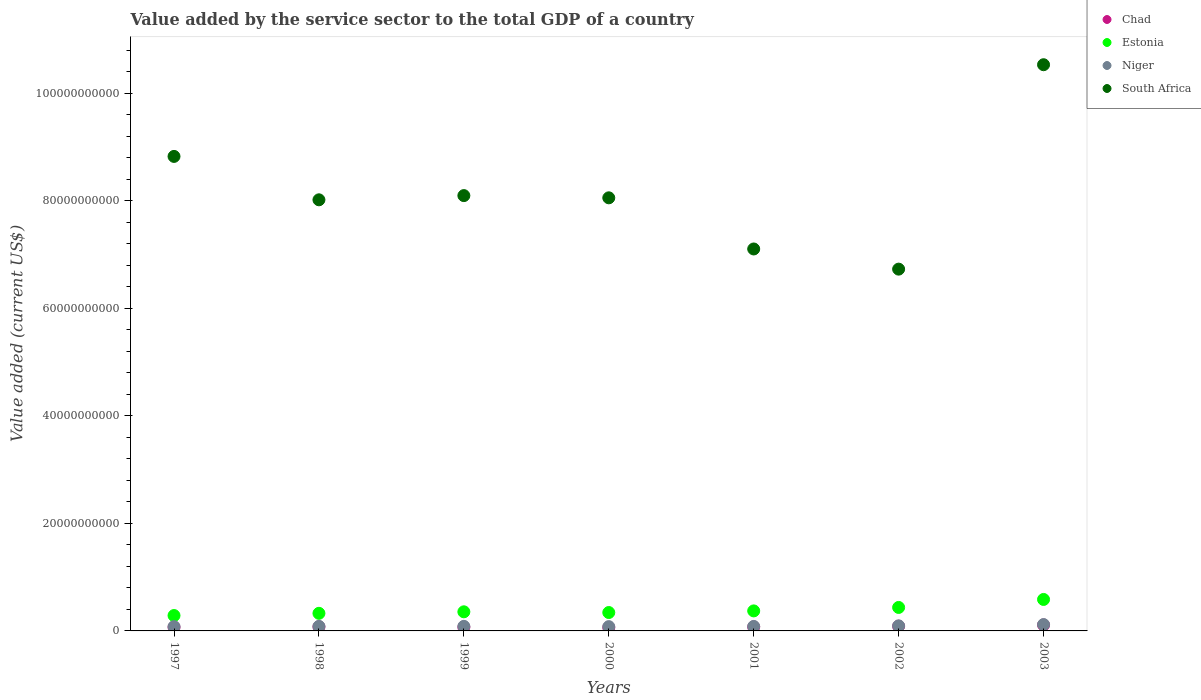What is the value added by the service sector to the total GDP in Estonia in 2000?
Your answer should be compact. 3.42e+09. Across all years, what is the maximum value added by the service sector to the total GDP in Chad?
Provide a succinct answer. 1.11e+09. Across all years, what is the minimum value added by the service sector to the total GDP in Estonia?
Provide a succinct answer. 2.86e+09. In which year was the value added by the service sector to the total GDP in South Africa maximum?
Make the answer very short. 2003. In which year was the value added by the service sector to the total GDP in Estonia minimum?
Ensure brevity in your answer.  1997. What is the total value added by the service sector to the total GDP in Niger in the graph?
Make the answer very short. 6.25e+09. What is the difference between the value added by the service sector to the total GDP in Estonia in 1999 and that in 2002?
Ensure brevity in your answer.  -8.11e+08. What is the difference between the value added by the service sector to the total GDP in Niger in 1998 and the value added by the service sector to the total GDP in Chad in 1997?
Offer a terse response. 1.65e+08. What is the average value added by the service sector to the total GDP in Niger per year?
Your answer should be compact. 8.93e+08. In the year 1999, what is the difference between the value added by the service sector to the total GDP in South Africa and value added by the service sector to the total GDP in Chad?
Offer a terse response. 8.03e+1. In how many years, is the value added by the service sector to the total GDP in Estonia greater than 44000000000 US$?
Give a very brief answer. 0. What is the ratio of the value added by the service sector to the total GDP in Chad in 2001 to that in 2003?
Your answer should be very brief. 0.66. Is the value added by the service sector to the total GDP in South Africa in 1998 less than that in 2000?
Provide a succinct answer. Yes. Is the difference between the value added by the service sector to the total GDP in South Africa in 1999 and 2002 greater than the difference between the value added by the service sector to the total GDP in Chad in 1999 and 2002?
Keep it short and to the point. Yes. What is the difference between the highest and the second highest value added by the service sector to the total GDP in Estonia?
Make the answer very short. 1.49e+09. What is the difference between the highest and the lowest value added by the service sector to the total GDP in Chad?
Your response must be concise. 4.88e+08. Is the sum of the value added by the service sector to the total GDP in South Africa in 1997 and 1998 greater than the maximum value added by the service sector to the total GDP in Chad across all years?
Keep it short and to the point. Yes. Is it the case that in every year, the sum of the value added by the service sector to the total GDP in Chad and value added by the service sector to the total GDP in South Africa  is greater than the sum of value added by the service sector to the total GDP in Niger and value added by the service sector to the total GDP in Estonia?
Ensure brevity in your answer.  Yes. Does the value added by the service sector to the total GDP in Estonia monotonically increase over the years?
Offer a very short reply. No. Is the value added by the service sector to the total GDP in Niger strictly greater than the value added by the service sector to the total GDP in Estonia over the years?
Offer a terse response. No. Is the value added by the service sector to the total GDP in South Africa strictly less than the value added by the service sector to the total GDP in Niger over the years?
Your response must be concise. No. How many dotlines are there?
Ensure brevity in your answer.  4. How many years are there in the graph?
Offer a terse response. 7. Does the graph contain grids?
Ensure brevity in your answer.  No. How are the legend labels stacked?
Your answer should be compact. Vertical. What is the title of the graph?
Make the answer very short. Value added by the service sector to the total GDP of a country. Does "Mauritius" appear as one of the legend labels in the graph?
Give a very brief answer. No. What is the label or title of the Y-axis?
Provide a short and direct response. Value added (current US$). What is the Value added (current US$) in Chad in 1997?
Your response must be concise. 6.79e+08. What is the Value added (current US$) in Estonia in 1997?
Your response must be concise. 2.86e+09. What is the Value added (current US$) in Niger in 1997?
Ensure brevity in your answer.  7.98e+08. What is the Value added (current US$) in South Africa in 1997?
Your response must be concise. 8.83e+1. What is the Value added (current US$) in Chad in 1998?
Keep it short and to the point. 7.62e+08. What is the Value added (current US$) of Estonia in 1998?
Your response must be concise. 3.27e+09. What is the Value added (current US$) of Niger in 1998?
Offer a very short reply. 8.44e+08. What is the Value added (current US$) in South Africa in 1998?
Keep it short and to the point. 8.02e+1. What is the Value added (current US$) in Chad in 1999?
Offer a terse response. 6.98e+08. What is the Value added (current US$) in Estonia in 1999?
Make the answer very short. 3.55e+09. What is the Value added (current US$) of Niger in 1999?
Keep it short and to the point. 8.50e+08. What is the Value added (current US$) in South Africa in 1999?
Your answer should be compact. 8.10e+1. What is the Value added (current US$) in Chad in 2000?
Give a very brief answer. 6.17e+08. What is the Value added (current US$) of Estonia in 2000?
Offer a very short reply. 3.42e+09. What is the Value added (current US$) in Niger in 2000?
Offer a very short reply. 7.98e+08. What is the Value added (current US$) of South Africa in 2000?
Offer a very short reply. 8.05e+1. What is the Value added (current US$) of Chad in 2001?
Your answer should be compact. 7.35e+08. What is the Value added (current US$) in Estonia in 2001?
Offer a very short reply. 3.72e+09. What is the Value added (current US$) of Niger in 2001?
Provide a short and direct response. 8.37e+08. What is the Value added (current US$) in South Africa in 2001?
Ensure brevity in your answer.  7.10e+1. What is the Value added (current US$) of Chad in 2002?
Ensure brevity in your answer.  8.73e+08. What is the Value added (current US$) in Estonia in 2002?
Offer a very short reply. 4.37e+09. What is the Value added (current US$) of Niger in 2002?
Give a very brief answer. 9.43e+08. What is the Value added (current US$) in South Africa in 2002?
Your response must be concise. 6.73e+1. What is the Value added (current US$) of Chad in 2003?
Offer a very short reply. 1.11e+09. What is the Value added (current US$) in Estonia in 2003?
Your answer should be compact. 5.85e+09. What is the Value added (current US$) of Niger in 2003?
Provide a short and direct response. 1.18e+09. What is the Value added (current US$) in South Africa in 2003?
Your answer should be very brief. 1.05e+11. Across all years, what is the maximum Value added (current US$) in Chad?
Your response must be concise. 1.11e+09. Across all years, what is the maximum Value added (current US$) in Estonia?
Make the answer very short. 5.85e+09. Across all years, what is the maximum Value added (current US$) in Niger?
Ensure brevity in your answer.  1.18e+09. Across all years, what is the maximum Value added (current US$) of South Africa?
Offer a terse response. 1.05e+11. Across all years, what is the minimum Value added (current US$) of Chad?
Make the answer very short. 6.17e+08. Across all years, what is the minimum Value added (current US$) of Estonia?
Offer a very short reply. 2.86e+09. Across all years, what is the minimum Value added (current US$) of Niger?
Keep it short and to the point. 7.98e+08. Across all years, what is the minimum Value added (current US$) of South Africa?
Offer a terse response. 6.73e+1. What is the total Value added (current US$) of Chad in the graph?
Offer a very short reply. 5.47e+09. What is the total Value added (current US$) in Estonia in the graph?
Make the answer very short. 2.71e+1. What is the total Value added (current US$) in Niger in the graph?
Your response must be concise. 6.25e+09. What is the total Value added (current US$) of South Africa in the graph?
Offer a terse response. 5.74e+11. What is the difference between the Value added (current US$) in Chad in 1997 and that in 1998?
Offer a very short reply. -8.28e+07. What is the difference between the Value added (current US$) of Estonia in 1997 and that in 1998?
Provide a short and direct response. -4.10e+08. What is the difference between the Value added (current US$) in Niger in 1997 and that in 1998?
Offer a terse response. -4.69e+07. What is the difference between the Value added (current US$) of South Africa in 1997 and that in 1998?
Provide a short and direct response. 8.07e+09. What is the difference between the Value added (current US$) of Chad in 1997 and that in 1999?
Ensure brevity in your answer.  -1.88e+07. What is the difference between the Value added (current US$) in Estonia in 1997 and that in 1999?
Offer a terse response. -6.93e+08. What is the difference between the Value added (current US$) in Niger in 1997 and that in 1999?
Give a very brief answer. -5.24e+07. What is the difference between the Value added (current US$) in South Africa in 1997 and that in 1999?
Offer a very short reply. 7.29e+09. What is the difference between the Value added (current US$) in Chad in 1997 and that in 2000?
Your answer should be very brief. 6.20e+07. What is the difference between the Value added (current US$) in Estonia in 1997 and that in 2000?
Make the answer very short. -5.60e+08. What is the difference between the Value added (current US$) of Niger in 1997 and that in 2000?
Give a very brief answer. -9.07e+05. What is the difference between the Value added (current US$) of South Africa in 1997 and that in 2000?
Your response must be concise. 7.70e+09. What is the difference between the Value added (current US$) of Chad in 1997 and that in 2001?
Your response must be concise. -5.56e+07. What is the difference between the Value added (current US$) in Estonia in 1997 and that in 2001?
Make the answer very short. -8.62e+08. What is the difference between the Value added (current US$) of Niger in 1997 and that in 2001?
Your answer should be very brief. -3.89e+07. What is the difference between the Value added (current US$) of South Africa in 1997 and that in 2001?
Your answer should be very brief. 1.72e+1. What is the difference between the Value added (current US$) in Chad in 1997 and that in 2002?
Your answer should be very brief. -1.94e+08. What is the difference between the Value added (current US$) in Estonia in 1997 and that in 2002?
Your answer should be very brief. -1.50e+09. What is the difference between the Value added (current US$) in Niger in 1997 and that in 2002?
Ensure brevity in your answer.  -1.45e+08. What is the difference between the Value added (current US$) in South Africa in 1997 and that in 2002?
Give a very brief answer. 2.10e+1. What is the difference between the Value added (current US$) in Chad in 1997 and that in 2003?
Provide a succinct answer. -4.26e+08. What is the difference between the Value added (current US$) of Estonia in 1997 and that in 2003?
Offer a very short reply. -2.99e+09. What is the difference between the Value added (current US$) in Niger in 1997 and that in 2003?
Keep it short and to the point. -3.83e+08. What is the difference between the Value added (current US$) in South Africa in 1997 and that in 2003?
Your response must be concise. -1.71e+1. What is the difference between the Value added (current US$) of Chad in 1998 and that in 1999?
Your answer should be compact. 6.40e+07. What is the difference between the Value added (current US$) of Estonia in 1998 and that in 1999?
Your answer should be compact. -2.82e+08. What is the difference between the Value added (current US$) of Niger in 1998 and that in 1999?
Give a very brief answer. -5.49e+06. What is the difference between the Value added (current US$) of South Africa in 1998 and that in 1999?
Make the answer very short. -7.83e+08. What is the difference between the Value added (current US$) of Chad in 1998 and that in 2000?
Provide a short and direct response. 1.45e+08. What is the difference between the Value added (current US$) in Estonia in 1998 and that in 2000?
Provide a short and direct response. -1.49e+08. What is the difference between the Value added (current US$) in Niger in 1998 and that in 2000?
Provide a succinct answer. 4.60e+07. What is the difference between the Value added (current US$) of South Africa in 1998 and that in 2000?
Ensure brevity in your answer.  -3.70e+08. What is the difference between the Value added (current US$) of Chad in 1998 and that in 2001?
Your answer should be compact. 2.72e+07. What is the difference between the Value added (current US$) of Estonia in 1998 and that in 2001?
Make the answer very short. -4.52e+08. What is the difference between the Value added (current US$) of Niger in 1998 and that in 2001?
Provide a succinct answer. 7.92e+06. What is the difference between the Value added (current US$) in South Africa in 1998 and that in 2001?
Your response must be concise. 9.14e+09. What is the difference between the Value added (current US$) in Chad in 1998 and that in 2002?
Your answer should be very brief. -1.11e+08. What is the difference between the Value added (current US$) in Estonia in 1998 and that in 2002?
Provide a short and direct response. -1.09e+09. What is the difference between the Value added (current US$) of Niger in 1998 and that in 2002?
Give a very brief answer. -9.85e+07. What is the difference between the Value added (current US$) in South Africa in 1998 and that in 2002?
Give a very brief answer. 1.29e+1. What is the difference between the Value added (current US$) in Chad in 1998 and that in 2003?
Provide a short and direct response. -3.43e+08. What is the difference between the Value added (current US$) in Estonia in 1998 and that in 2003?
Your answer should be very brief. -2.58e+09. What is the difference between the Value added (current US$) of Niger in 1998 and that in 2003?
Offer a terse response. -3.36e+08. What is the difference between the Value added (current US$) in South Africa in 1998 and that in 2003?
Provide a short and direct response. -2.51e+1. What is the difference between the Value added (current US$) of Chad in 1999 and that in 2000?
Keep it short and to the point. 8.07e+07. What is the difference between the Value added (current US$) of Estonia in 1999 and that in 2000?
Keep it short and to the point. 1.33e+08. What is the difference between the Value added (current US$) of Niger in 1999 and that in 2000?
Provide a short and direct response. 5.14e+07. What is the difference between the Value added (current US$) of South Africa in 1999 and that in 2000?
Ensure brevity in your answer.  4.12e+08. What is the difference between the Value added (current US$) of Chad in 1999 and that in 2001?
Your answer should be very brief. -3.68e+07. What is the difference between the Value added (current US$) of Estonia in 1999 and that in 2001?
Your response must be concise. -1.70e+08. What is the difference between the Value added (current US$) in Niger in 1999 and that in 2001?
Give a very brief answer. 1.34e+07. What is the difference between the Value added (current US$) of South Africa in 1999 and that in 2001?
Your answer should be compact. 9.92e+09. What is the difference between the Value added (current US$) in Chad in 1999 and that in 2002?
Give a very brief answer. -1.75e+08. What is the difference between the Value added (current US$) in Estonia in 1999 and that in 2002?
Ensure brevity in your answer.  -8.11e+08. What is the difference between the Value added (current US$) in Niger in 1999 and that in 2002?
Provide a short and direct response. -9.30e+07. What is the difference between the Value added (current US$) in South Africa in 1999 and that in 2002?
Provide a succinct answer. 1.37e+1. What is the difference between the Value added (current US$) of Chad in 1999 and that in 2003?
Make the answer very short. -4.07e+08. What is the difference between the Value added (current US$) of Estonia in 1999 and that in 2003?
Provide a succinct answer. -2.30e+09. What is the difference between the Value added (current US$) in Niger in 1999 and that in 2003?
Your answer should be compact. -3.31e+08. What is the difference between the Value added (current US$) of South Africa in 1999 and that in 2003?
Keep it short and to the point. -2.43e+1. What is the difference between the Value added (current US$) in Chad in 2000 and that in 2001?
Your response must be concise. -1.18e+08. What is the difference between the Value added (current US$) in Estonia in 2000 and that in 2001?
Your answer should be very brief. -3.03e+08. What is the difference between the Value added (current US$) of Niger in 2000 and that in 2001?
Provide a short and direct response. -3.80e+07. What is the difference between the Value added (current US$) of South Africa in 2000 and that in 2001?
Your answer should be very brief. 9.51e+09. What is the difference between the Value added (current US$) in Chad in 2000 and that in 2002?
Make the answer very short. -2.56e+08. What is the difference between the Value added (current US$) in Estonia in 2000 and that in 2002?
Your answer should be very brief. -9.45e+08. What is the difference between the Value added (current US$) in Niger in 2000 and that in 2002?
Offer a very short reply. -1.44e+08. What is the difference between the Value added (current US$) of South Africa in 2000 and that in 2002?
Offer a very short reply. 1.33e+1. What is the difference between the Value added (current US$) of Chad in 2000 and that in 2003?
Your response must be concise. -4.88e+08. What is the difference between the Value added (current US$) in Estonia in 2000 and that in 2003?
Provide a succinct answer. -2.43e+09. What is the difference between the Value added (current US$) of Niger in 2000 and that in 2003?
Provide a short and direct response. -3.82e+08. What is the difference between the Value added (current US$) in South Africa in 2000 and that in 2003?
Make the answer very short. -2.48e+1. What is the difference between the Value added (current US$) in Chad in 2001 and that in 2002?
Give a very brief answer. -1.38e+08. What is the difference between the Value added (current US$) in Estonia in 2001 and that in 2002?
Your answer should be compact. -6.42e+08. What is the difference between the Value added (current US$) of Niger in 2001 and that in 2002?
Ensure brevity in your answer.  -1.06e+08. What is the difference between the Value added (current US$) in South Africa in 2001 and that in 2002?
Your answer should be very brief. 3.75e+09. What is the difference between the Value added (current US$) of Chad in 2001 and that in 2003?
Your answer should be very brief. -3.71e+08. What is the difference between the Value added (current US$) of Estonia in 2001 and that in 2003?
Keep it short and to the point. -2.13e+09. What is the difference between the Value added (current US$) in Niger in 2001 and that in 2003?
Offer a very short reply. -3.44e+08. What is the difference between the Value added (current US$) in South Africa in 2001 and that in 2003?
Provide a succinct answer. -3.43e+1. What is the difference between the Value added (current US$) of Chad in 2002 and that in 2003?
Provide a short and direct response. -2.32e+08. What is the difference between the Value added (current US$) in Estonia in 2002 and that in 2003?
Ensure brevity in your answer.  -1.49e+09. What is the difference between the Value added (current US$) in Niger in 2002 and that in 2003?
Your answer should be compact. -2.38e+08. What is the difference between the Value added (current US$) in South Africa in 2002 and that in 2003?
Offer a terse response. -3.80e+1. What is the difference between the Value added (current US$) in Chad in 1997 and the Value added (current US$) in Estonia in 1998?
Provide a short and direct response. -2.59e+09. What is the difference between the Value added (current US$) in Chad in 1997 and the Value added (current US$) in Niger in 1998?
Provide a short and direct response. -1.65e+08. What is the difference between the Value added (current US$) in Chad in 1997 and the Value added (current US$) in South Africa in 1998?
Offer a terse response. -7.95e+1. What is the difference between the Value added (current US$) in Estonia in 1997 and the Value added (current US$) in Niger in 1998?
Your answer should be very brief. 2.02e+09. What is the difference between the Value added (current US$) in Estonia in 1997 and the Value added (current US$) in South Africa in 1998?
Ensure brevity in your answer.  -7.73e+1. What is the difference between the Value added (current US$) in Niger in 1997 and the Value added (current US$) in South Africa in 1998?
Offer a very short reply. -7.94e+1. What is the difference between the Value added (current US$) of Chad in 1997 and the Value added (current US$) of Estonia in 1999?
Your response must be concise. -2.88e+09. What is the difference between the Value added (current US$) in Chad in 1997 and the Value added (current US$) in Niger in 1999?
Your answer should be very brief. -1.71e+08. What is the difference between the Value added (current US$) in Chad in 1997 and the Value added (current US$) in South Africa in 1999?
Give a very brief answer. -8.03e+1. What is the difference between the Value added (current US$) in Estonia in 1997 and the Value added (current US$) in Niger in 1999?
Keep it short and to the point. 2.01e+09. What is the difference between the Value added (current US$) of Estonia in 1997 and the Value added (current US$) of South Africa in 1999?
Offer a terse response. -7.81e+1. What is the difference between the Value added (current US$) of Niger in 1997 and the Value added (current US$) of South Africa in 1999?
Your response must be concise. -8.02e+1. What is the difference between the Value added (current US$) of Chad in 1997 and the Value added (current US$) of Estonia in 2000?
Ensure brevity in your answer.  -2.74e+09. What is the difference between the Value added (current US$) in Chad in 1997 and the Value added (current US$) in Niger in 2000?
Provide a succinct answer. -1.19e+08. What is the difference between the Value added (current US$) in Chad in 1997 and the Value added (current US$) in South Africa in 2000?
Offer a very short reply. -7.99e+1. What is the difference between the Value added (current US$) in Estonia in 1997 and the Value added (current US$) in Niger in 2000?
Keep it short and to the point. 2.06e+09. What is the difference between the Value added (current US$) in Estonia in 1997 and the Value added (current US$) in South Africa in 2000?
Your answer should be compact. -7.77e+1. What is the difference between the Value added (current US$) in Niger in 1997 and the Value added (current US$) in South Africa in 2000?
Offer a very short reply. -7.98e+1. What is the difference between the Value added (current US$) in Chad in 1997 and the Value added (current US$) in Estonia in 2001?
Your answer should be very brief. -3.05e+09. What is the difference between the Value added (current US$) in Chad in 1997 and the Value added (current US$) in Niger in 2001?
Give a very brief answer. -1.57e+08. What is the difference between the Value added (current US$) of Chad in 1997 and the Value added (current US$) of South Africa in 2001?
Offer a terse response. -7.04e+1. What is the difference between the Value added (current US$) of Estonia in 1997 and the Value added (current US$) of Niger in 2001?
Offer a very short reply. 2.03e+09. What is the difference between the Value added (current US$) in Estonia in 1997 and the Value added (current US$) in South Africa in 2001?
Your answer should be very brief. -6.82e+1. What is the difference between the Value added (current US$) in Niger in 1997 and the Value added (current US$) in South Africa in 2001?
Ensure brevity in your answer.  -7.02e+1. What is the difference between the Value added (current US$) in Chad in 1997 and the Value added (current US$) in Estonia in 2002?
Provide a short and direct response. -3.69e+09. What is the difference between the Value added (current US$) of Chad in 1997 and the Value added (current US$) of Niger in 2002?
Provide a short and direct response. -2.63e+08. What is the difference between the Value added (current US$) in Chad in 1997 and the Value added (current US$) in South Africa in 2002?
Offer a very short reply. -6.66e+1. What is the difference between the Value added (current US$) of Estonia in 1997 and the Value added (current US$) of Niger in 2002?
Provide a short and direct response. 1.92e+09. What is the difference between the Value added (current US$) in Estonia in 1997 and the Value added (current US$) in South Africa in 2002?
Offer a very short reply. -6.44e+1. What is the difference between the Value added (current US$) in Niger in 1997 and the Value added (current US$) in South Africa in 2002?
Your answer should be very brief. -6.65e+1. What is the difference between the Value added (current US$) in Chad in 1997 and the Value added (current US$) in Estonia in 2003?
Your answer should be very brief. -5.17e+09. What is the difference between the Value added (current US$) of Chad in 1997 and the Value added (current US$) of Niger in 2003?
Provide a succinct answer. -5.01e+08. What is the difference between the Value added (current US$) of Chad in 1997 and the Value added (current US$) of South Africa in 2003?
Make the answer very short. -1.05e+11. What is the difference between the Value added (current US$) in Estonia in 1997 and the Value added (current US$) in Niger in 2003?
Offer a very short reply. 1.68e+09. What is the difference between the Value added (current US$) of Estonia in 1997 and the Value added (current US$) of South Africa in 2003?
Your response must be concise. -1.02e+11. What is the difference between the Value added (current US$) of Niger in 1997 and the Value added (current US$) of South Africa in 2003?
Your answer should be compact. -1.05e+11. What is the difference between the Value added (current US$) in Chad in 1998 and the Value added (current US$) in Estonia in 1999?
Your answer should be compact. -2.79e+09. What is the difference between the Value added (current US$) in Chad in 1998 and the Value added (current US$) in Niger in 1999?
Provide a succinct answer. -8.77e+07. What is the difference between the Value added (current US$) of Chad in 1998 and the Value added (current US$) of South Africa in 1999?
Make the answer very short. -8.02e+1. What is the difference between the Value added (current US$) in Estonia in 1998 and the Value added (current US$) in Niger in 1999?
Provide a short and direct response. 2.42e+09. What is the difference between the Value added (current US$) in Estonia in 1998 and the Value added (current US$) in South Africa in 1999?
Offer a very short reply. -7.77e+1. What is the difference between the Value added (current US$) in Niger in 1998 and the Value added (current US$) in South Africa in 1999?
Keep it short and to the point. -8.01e+1. What is the difference between the Value added (current US$) of Chad in 1998 and the Value added (current US$) of Estonia in 2000?
Provide a succinct answer. -2.66e+09. What is the difference between the Value added (current US$) in Chad in 1998 and the Value added (current US$) in Niger in 2000?
Your answer should be compact. -3.63e+07. What is the difference between the Value added (current US$) in Chad in 1998 and the Value added (current US$) in South Africa in 2000?
Keep it short and to the point. -7.98e+1. What is the difference between the Value added (current US$) in Estonia in 1998 and the Value added (current US$) in Niger in 2000?
Offer a terse response. 2.47e+09. What is the difference between the Value added (current US$) of Estonia in 1998 and the Value added (current US$) of South Africa in 2000?
Provide a short and direct response. -7.73e+1. What is the difference between the Value added (current US$) of Niger in 1998 and the Value added (current US$) of South Africa in 2000?
Ensure brevity in your answer.  -7.97e+1. What is the difference between the Value added (current US$) in Chad in 1998 and the Value added (current US$) in Estonia in 2001?
Keep it short and to the point. -2.96e+09. What is the difference between the Value added (current US$) of Chad in 1998 and the Value added (current US$) of Niger in 2001?
Offer a very short reply. -7.43e+07. What is the difference between the Value added (current US$) of Chad in 1998 and the Value added (current US$) of South Africa in 2001?
Provide a succinct answer. -7.03e+1. What is the difference between the Value added (current US$) in Estonia in 1998 and the Value added (current US$) in Niger in 2001?
Provide a succinct answer. 2.44e+09. What is the difference between the Value added (current US$) in Estonia in 1998 and the Value added (current US$) in South Africa in 2001?
Offer a very short reply. -6.78e+1. What is the difference between the Value added (current US$) of Niger in 1998 and the Value added (current US$) of South Africa in 2001?
Make the answer very short. -7.02e+1. What is the difference between the Value added (current US$) of Chad in 1998 and the Value added (current US$) of Estonia in 2002?
Ensure brevity in your answer.  -3.60e+09. What is the difference between the Value added (current US$) of Chad in 1998 and the Value added (current US$) of Niger in 2002?
Keep it short and to the point. -1.81e+08. What is the difference between the Value added (current US$) of Chad in 1998 and the Value added (current US$) of South Africa in 2002?
Provide a succinct answer. -6.65e+1. What is the difference between the Value added (current US$) of Estonia in 1998 and the Value added (current US$) of Niger in 2002?
Provide a short and direct response. 2.33e+09. What is the difference between the Value added (current US$) of Estonia in 1998 and the Value added (current US$) of South Africa in 2002?
Your answer should be compact. -6.40e+1. What is the difference between the Value added (current US$) in Niger in 1998 and the Value added (current US$) in South Africa in 2002?
Provide a succinct answer. -6.64e+1. What is the difference between the Value added (current US$) of Chad in 1998 and the Value added (current US$) of Estonia in 2003?
Give a very brief answer. -5.09e+09. What is the difference between the Value added (current US$) in Chad in 1998 and the Value added (current US$) in Niger in 2003?
Your answer should be compact. -4.19e+08. What is the difference between the Value added (current US$) of Chad in 1998 and the Value added (current US$) of South Africa in 2003?
Give a very brief answer. -1.05e+11. What is the difference between the Value added (current US$) of Estonia in 1998 and the Value added (current US$) of Niger in 2003?
Your answer should be compact. 2.09e+09. What is the difference between the Value added (current US$) in Estonia in 1998 and the Value added (current US$) in South Africa in 2003?
Your response must be concise. -1.02e+11. What is the difference between the Value added (current US$) in Niger in 1998 and the Value added (current US$) in South Africa in 2003?
Keep it short and to the point. -1.04e+11. What is the difference between the Value added (current US$) in Chad in 1999 and the Value added (current US$) in Estonia in 2000?
Your response must be concise. -2.72e+09. What is the difference between the Value added (current US$) of Chad in 1999 and the Value added (current US$) of Niger in 2000?
Offer a terse response. -1.00e+08. What is the difference between the Value added (current US$) in Chad in 1999 and the Value added (current US$) in South Africa in 2000?
Keep it short and to the point. -7.99e+1. What is the difference between the Value added (current US$) of Estonia in 1999 and the Value added (current US$) of Niger in 2000?
Make the answer very short. 2.76e+09. What is the difference between the Value added (current US$) of Estonia in 1999 and the Value added (current US$) of South Africa in 2000?
Provide a succinct answer. -7.70e+1. What is the difference between the Value added (current US$) in Niger in 1999 and the Value added (current US$) in South Africa in 2000?
Make the answer very short. -7.97e+1. What is the difference between the Value added (current US$) in Chad in 1999 and the Value added (current US$) in Estonia in 2001?
Your answer should be compact. -3.03e+09. What is the difference between the Value added (current US$) of Chad in 1999 and the Value added (current US$) of Niger in 2001?
Your response must be concise. -1.38e+08. What is the difference between the Value added (current US$) of Chad in 1999 and the Value added (current US$) of South Africa in 2001?
Give a very brief answer. -7.03e+1. What is the difference between the Value added (current US$) in Estonia in 1999 and the Value added (current US$) in Niger in 2001?
Provide a short and direct response. 2.72e+09. What is the difference between the Value added (current US$) of Estonia in 1999 and the Value added (current US$) of South Africa in 2001?
Your response must be concise. -6.75e+1. What is the difference between the Value added (current US$) of Niger in 1999 and the Value added (current US$) of South Africa in 2001?
Give a very brief answer. -7.02e+1. What is the difference between the Value added (current US$) of Chad in 1999 and the Value added (current US$) of Estonia in 2002?
Your answer should be very brief. -3.67e+09. What is the difference between the Value added (current US$) of Chad in 1999 and the Value added (current US$) of Niger in 2002?
Offer a terse response. -2.45e+08. What is the difference between the Value added (current US$) in Chad in 1999 and the Value added (current US$) in South Africa in 2002?
Your response must be concise. -6.66e+1. What is the difference between the Value added (current US$) of Estonia in 1999 and the Value added (current US$) of Niger in 2002?
Give a very brief answer. 2.61e+09. What is the difference between the Value added (current US$) in Estonia in 1999 and the Value added (current US$) in South Africa in 2002?
Provide a short and direct response. -6.37e+1. What is the difference between the Value added (current US$) of Niger in 1999 and the Value added (current US$) of South Africa in 2002?
Your response must be concise. -6.64e+1. What is the difference between the Value added (current US$) in Chad in 1999 and the Value added (current US$) in Estonia in 2003?
Your answer should be very brief. -5.15e+09. What is the difference between the Value added (current US$) in Chad in 1999 and the Value added (current US$) in Niger in 2003?
Ensure brevity in your answer.  -4.83e+08. What is the difference between the Value added (current US$) of Chad in 1999 and the Value added (current US$) of South Africa in 2003?
Ensure brevity in your answer.  -1.05e+11. What is the difference between the Value added (current US$) in Estonia in 1999 and the Value added (current US$) in Niger in 2003?
Offer a very short reply. 2.37e+09. What is the difference between the Value added (current US$) in Estonia in 1999 and the Value added (current US$) in South Africa in 2003?
Your answer should be very brief. -1.02e+11. What is the difference between the Value added (current US$) in Niger in 1999 and the Value added (current US$) in South Africa in 2003?
Your response must be concise. -1.04e+11. What is the difference between the Value added (current US$) of Chad in 2000 and the Value added (current US$) of Estonia in 2001?
Keep it short and to the point. -3.11e+09. What is the difference between the Value added (current US$) of Chad in 2000 and the Value added (current US$) of Niger in 2001?
Make the answer very short. -2.19e+08. What is the difference between the Value added (current US$) in Chad in 2000 and the Value added (current US$) in South Africa in 2001?
Provide a short and direct response. -7.04e+1. What is the difference between the Value added (current US$) in Estonia in 2000 and the Value added (current US$) in Niger in 2001?
Provide a short and direct response. 2.59e+09. What is the difference between the Value added (current US$) of Estonia in 2000 and the Value added (current US$) of South Africa in 2001?
Ensure brevity in your answer.  -6.76e+1. What is the difference between the Value added (current US$) of Niger in 2000 and the Value added (current US$) of South Africa in 2001?
Provide a short and direct response. -7.02e+1. What is the difference between the Value added (current US$) of Chad in 2000 and the Value added (current US$) of Estonia in 2002?
Make the answer very short. -3.75e+09. What is the difference between the Value added (current US$) of Chad in 2000 and the Value added (current US$) of Niger in 2002?
Offer a very short reply. -3.25e+08. What is the difference between the Value added (current US$) in Chad in 2000 and the Value added (current US$) in South Africa in 2002?
Give a very brief answer. -6.67e+1. What is the difference between the Value added (current US$) in Estonia in 2000 and the Value added (current US$) in Niger in 2002?
Ensure brevity in your answer.  2.48e+09. What is the difference between the Value added (current US$) of Estonia in 2000 and the Value added (current US$) of South Africa in 2002?
Offer a terse response. -6.39e+1. What is the difference between the Value added (current US$) of Niger in 2000 and the Value added (current US$) of South Africa in 2002?
Ensure brevity in your answer.  -6.65e+1. What is the difference between the Value added (current US$) in Chad in 2000 and the Value added (current US$) in Estonia in 2003?
Make the answer very short. -5.24e+09. What is the difference between the Value added (current US$) of Chad in 2000 and the Value added (current US$) of Niger in 2003?
Your answer should be compact. -5.63e+08. What is the difference between the Value added (current US$) in Chad in 2000 and the Value added (current US$) in South Africa in 2003?
Offer a very short reply. -1.05e+11. What is the difference between the Value added (current US$) in Estonia in 2000 and the Value added (current US$) in Niger in 2003?
Offer a very short reply. 2.24e+09. What is the difference between the Value added (current US$) in Estonia in 2000 and the Value added (current US$) in South Africa in 2003?
Ensure brevity in your answer.  -1.02e+11. What is the difference between the Value added (current US$) in Niger in 2000 and the Value added (current US$) in South Africa in 2003?
Your answer should be very brief. -1.05e+11. What is the difference between the Value added (current US$) in Chad in 2001 and the Value added (current US$) in Estonia in 2002?
Your response must be concise. -3.63e+09. What is the difference between the Value added (current US$) in Chad in 2001 and the Value added (current US$) in Niger in 2002?
Ensure brevity in your answer.  -2.08e+08. What is the difference between the Value added (current US$) of Chad in 2001 and the Value added (current US$) of South Africa in 2002?
Make the answer very short. -6.66e+1. What is the difference between the Value added (current US$) of Estonia in 2001 and the Value added (current US$) of Niger in 2002?
Keep it short and to the point. 2.78e+09. What is the difference between the Value added (current US$) of Estonia in 2001 and the Value added (current US$) of South Africa in 2002?
Provide a succinct answer. -6.36e+1. What is the difference between the Value added (current US$) of Niger in 2001 and the Value added (current US$) of South Africa in 2002?
Provide a short and direct response. -6.64e+1. What is the difference between the Value added (current US$) in Chad in 2001 and the Value added (current US$) in Estonia in 2003?
Offer a very short reply. -5.12e+09. What is the difference between the Value added (current US$) of Chad in 2001 and the Value added (current US$) of Niger in 2003?
Provide a succinct answer. -4.46e+08. What is the difference between the Value added (current US$) in Chad in 2001 and the Value added (current US$) in South Africa in 2003?
Make the answer very short. -1.05e+11. What is the difference between the Value added (current US$) in Estonia in 2001 and the Value added (current US$) in Niger in 2003?
Offer a terse response. 2.54e+09. What is the difference between the Value added (current US$) of Estonia in 2001 and the Value added (current US$) of South Africa in 2003?
Give a very brief answer. -1.02e+11. What is the difference between the Value added (current US$) in Niger in 2001 and the Value added (current US$) in South Africa in 2003?
Provide a short and direct response. -1.04e+11. What is the difference between the Value added (current US$) in Chad in 2002 and the Value added (current US$) in Estonia in 2003?
Give a very brief answer. -4.98e+09. What is the difference between the Value added (current US$) of Chad in 2002 and the Value added (current US$) of Niger in 2003?
Ensure brevity in your answer.  -3.08e+08. What is the difference between the Value added (current US$) in Chad in 2002 and the Value added (current US$) in South Africa in 2003?
Ensure brevity in your answer.  -1.04e+11. What is the difference between the Value added (current US$) of Estonia in 2002 and the Value added (current US$) of Niger in 2003?
Provide a short and direct response. 3.19e+09. What is the difference between the Value added (current US$) in Estonia in 2002 and the Value added (current US$) in South Africa in 2003?
Provide a succinct answer. -1.01e+11. What is the difference between the Value added (current US$) of Niger in 2002 and the Value added (current US$) of South Africa in 2003?
Your answer should be very brief. -1.04e+11. What is the average Value added (current US$) of Chad per year?
Offer a very short reply. 7.82e+08. What is the average Value added (current US$) of Estonia per year?
Your response must be concise. 3.86e+09. What is the average Value added (current US$) in Niger per year?
Your response must be concise. 8.93e+08. What is the average Value added (current US$) in South Africa per year?
Provide a succinct answer. 8.19e+1. In the year 1997, what is the difference between the Value added (current US$) in Chad and Value added (current US$) in Estonia?
Provide a short and direct response. -2.18e+09. In the year 1997, what is the difference between the Value added (current US$) in Chad and Value added (current US$) in Niger?
Your response must be concise. -1.18e+08. In the year 1997, what is the difference between the Value added (current US$) of Chad and Value added (current US$) of South Africa?
Make the answer very short. -8.76e+1. In the year 1997, what is the difference between the Value added (current US$) of Estonia and Value added (current US$) of Niger?
Give a very brief answer. 2.06e+09. In the year 1997, what is the difference between the Value added (current US$) in Estonia and Value added (current US$) in South Africa?
Provide a short and direct response. -8.54e+1. In the year 1997, what is the difference between the Value added (current US$) of Niger and Value added (current US$) of South Africa?
Keep it short and to the point. -8.75e+1. In the year 1998, what is the difference between the Value added (current US$) of Chad and Value added (current US$) of Estonia?
Make the answer very short. -2.51e+09. In the year 1998, what is the difference between the Value added (current US$) of Chad and Value added (current US$) of Niger?
Provide a succinct answer. -8.23e+07. In the year 1998, what is the difference between the Value added (current US$) of Chad and Value added (current US$) of South Africa?
Your response must be concise. -7.94e+1. In the year 1998, what is the difference between the Value added (current US$) in Estonia and Value added (current US$) in Niger?
Give a very brief answer. 2.43e+09. In the year 1998, what is the difference between the Value added (current US$) of Estonia and Value added (current US$) of South Africa?
Provide a short and direct response. -7.69e+1. In the year 1998, what is the difference between the Value added (current US$) in Niger and Value added (current US$) in South Africa?
Provide a succinct answer. -7.93e+1. In the year 1999, what is the difference between the Value added (current US$) in Chad and Value added (current US$) in Estonia?
Make the answer very short. -2.86e+09. In the year 1999, what is the difference between the Value added (current US$) in Chad and Value added (current US$) in Niger?
Ensure brevity in your answer.  -1.52e+08. In the year 1999, what is the difference between the Value added (current US$) in Chad and Value added (current US$) in South Africa?
Keep it short and to the point. -8.03e+1. In the year 1999, what is the difference between the Value added (current US$) of Estonia and Value added (current US$) of Niger?
Make the answer very short. 2.70e+09. In the year 1999, what is the difference between the Value added (current US$) of Estonia and Value added (current US$) of South Africa?
Make the answer very short. -7.74e+1. In the year 1999, what is the difference between the Value added (current US$) in Niger and Value added (current US$) in South Africa?
Offer a terse response. -8.01e+1. In the year 2000, what is the difference between the Value added (current US$) in Chad and Value added (current US$) in Estonia?
Ensure brevity in your answer.  -2.80e+09. In the year 2000, what is the difference between the Value added (current US$) in Chad and Value added (current US$) in Niger?
Your answer should be compact. -1.81e+08. In the year 2000, what is the difference between the Value added (current US$) in Chad and Value added (current US$) in South Africa?
Keep it short and to the point. -7.99e+1. In the year 2000, what is the difference between the Value added (current US$) in Estonia and Value added (current US$) in Niger?
Offer a very short reply. 2.62e+09. In the year 2000, what is the difference between the Value added (current US$) in Estonia and Value added (current US$) in South Africa?
Keep it short and to the point. -7.71e+1. In the year 2000, what is the difference between the Value added (current US$) of Niger and Value added (current US$) of South Africa?
Your answer should be very brief. -7.98e+1. In the year 2001, what is the difference between the Value added (current US$) in Chad and Value added (current US$) in Estonia?
Your response must be concise. -2.99e+09. In the year 2001, what is the difference between the Value added (current US$) in Chad and Value added (current US$) in Niger?
Your answer should be compact. -1.02e+08. In the year 2001, what is the difference between the Value added (current US$) in Chad and Value added (current US$) in South Africa?
Your response must be concise. -7.03e+1. In the year 2001, what is the difference between the Value added (current US$) of Estonia and Value added (current US$) of Niger?
Your answer should be very brief. 2.89e+09. In the year 2001, what is the difference between the Value added (current US$) of Estonia and Value added (current US$) of South Africa?
Provide a short and direct response. -6.73e+1. In the year 2001, what is the difference between the Value added (current US$) of Niger and Value added (current US$) of South Africa?
Your response must be concise. -7.02e+1. In the year 2002, what is the difference between the Value added (current US$) of Chad and Value added (current US$) of Estonia?
Your answer should be compact. -3.49e+09. In the year 2002, what is the difference between the Value added (current US$) in Chad and Value added (current US$) in Niger?
Provide a short and direct response. -6.97e+07. In the year 2002, what is the difference between the Value added (current US$) in Chad and Value added (current US$) in South Africa?
Your response must be concise. -6.64e+1. In the year 2002, what is the difference between the Value added (current US$) of Estonia and Value added (current US$) of Niger?
Provide a short and direct response. 3.42e+09. In the year 2002, what is the difference between the Value added (current US$) of Estonia and Value added (current US$) of South Africa?
Your response must be concise. -6.29e+1. In the year 2002, what is the difference between the Value added (current US$) of Niger and Value added (current US$) of South Africa?
Your answer should be compact. -6.63e+1. In the year 2003, what is the difference between the Value added (current US$) in Chad and Value added (current US$) in Estonia?
Provide a short and direct response. -4.75e+09. In the year 2003, what is the difference between the Value added (current US$) in Chad and Value added (current US$) in Niger?
Your answer should be compact. -7.53e+07. In the year 2003, what is the difference between the Value added (current US$) of Chad and Value added (current US$) of South Africa?
Provide a short and direct response. -1.04e+11. In the year 2003, what is the difference between the Value added (current US$) in Estonia and Value added (current US$) in Niger?
Make the answer very short. 4.67e+09. In the year 2003, what is the difference between the Value added (current US$) in Estonia and Value added (current US$) in South Africa?
Your response must be concise. -9.95e+1. In the year 2003, what is the difference between the Value added (current US$) in Niger and Value added (current US$) in South Africa?
Provide a succinct answer. -1.04e+11. What is the ratio of the Value added (current US$) of Chad in 1997 to that in 1998?
Ensure brevity in your answer.  0.89. What is the ratio of the Value added (current US$) of Estonia in 1997 to that in 1998?
Keep it short and to the point. 0.87. What is the ratio of the Value added (current US$) of Niger in 1997 to that in 1998?
Offer a very short reply. 0.94. What is the ratio of the Value added (current US$) in South Africa in 1997 to that in 1998?
Provide a succinct answer. 1.1. What is the ratio of the Value added (current US$) of Chad in 1997 to that in 1999?
Keep it short and to the point. 0.97. What is the ratio of the Value added (current US$) of Estonia in 1997 to that in 1999?
Offer a very short reply. 0.81. What is the ratio of the Value added (current US$) of Niger in 1997 to that in 1999?
Make the answer very short. 0.94. What is the ratio of the Value added (current US$) in South Africa in 1997 to that in 1999?
Your response must be concise. 1.09. What is the ratio of the Value added (current US$) of Chad in 1997 to that in 2000?
Your answer should be compact. 1.1. What is the ratio of the Value added (current US$) of Estonia in 1997 to that in 2000?
Offer a terse response. 0.84. What is the ratio of the Value added (current US$) of Niger in 1997 to that in 2000?
Offer a terse response. 1. What is the ratio of the Value added (current US$) of South Africa in 1997 to that in 2000?
Your answer should be very brief. 1.1. What is the ratio of the Value added (current US$) of Chad in 1997 to that in 2001?
Give a very brief answer. 0.92. What is the ratio of the Value added (current US$) in Estonia in 1997 to that in 2001?
Give a very brief answer. 0.77. What is the ratio of the Value added (current US$) in Niger in 1997 to that in 2001?
Your response must be concise. 0.95. What is the ratio of the Value added (current US$) in South Africa in 1997 to that in 2001?
Your answer should be compact. 1.24. What is the ratio of the Value added (current US$) in Chad in 1997 to that in 2002?
Provide a succinct answer. 0.78. What is the ratio of the Value added (current US$) in Estonia in 1997 to that in 2002?
Make the answer very short. 0.66. What is the ratio of the Value added (current US$) in Niger in 1997 to that in 2002?
Provide a succinct answer. 0.85. What is the ratio of the Value added (current US$) of South Africa in 1997 to that in 2002?
Provide a short and direct response. 1.31. What is the ratio of the Value added (current US$) of Chad in 1997 to that in 2003?
Give a very brief answer. 0.61. What is the ratio of the Value added (current US$) of Estonia in 1997 to that in 2003?
Give a very brief answer. 0.49. What is the ratio of the Value added (current US$) of Niger in 1997 to that in 2003?
Provide a short and direct response. 0.68. What is the ratio of the Value added (current US$) in South Africa in 1997 to that in 2003?
Provide a short and direct response. 0.84. What is the ratio of the Value added (current US$) in Chad in 1998 to that in 1999?
Provide a short and direct response. 1.09. What is the ratio of the Value added (current US$) of Estonia in 1998 to that in 1999?
Your answer should be very brief. 0.92. What is the ratio of the Value added (current US$) in South Africa in 1998 to that in 1999?
Provide a succinct answer. 0.99. What is the ratio of the Value added (current US$) in Chad in 1998 to that in 2000?
Your response must be concise. 1.23. What is the ratio of the Value added (current US$) in Estonia in 1998 to that in 2000?
Offer a terse response. 0.96. What is the ratio of the Value added (current US$) in Niger in 1998 to that in 2000?
Provide a short and direct response. 1.06. What is the ratio of the Value added (current US$) in South Africa in 1998 to that in 2000?
Provide a short and direct response. 1. What is the ratio of the Value added (current US$) in Chad in 1998 to that in 2001?
Your answer should be very brief. 1.04. What is the ratio of the Value added (current US$) in Estonia in 1998 to that in 2001?
Provide a succinct answer. 0.88. What is the ratio of the Value added (current US$) of Niger in 1998 to that in 2001?
Give a very brief answer. 1.01. What is the ratio of the Value added (current US$) in South Africa in 1998 to that in 2001?
Provide a succinct answer. 1.13. What is the ratio of the Value added (current US$) in Chad in 1998 to that in 2002?
Ensure brevity in your answer.  0.87. What is the ratio of the Value added (current US$) in Estonia in 1998 to that in 2002?
Your answer should be very brief. 0.75. What is the ratio of the Value added (current US$) in Niger in 1998 to that in 2002?
Offer a very short reply. 0.9. What is the ratio of the Value added (current US$) of South Africa in 1998 to that in 2002?
Provide a short and direct response. 1.19. What is the ratio of the Value added (current US$) of Chad in 1998 to that in 2003?
Your answer should be very brief. 0.69. What is the ratio of the Value added (current US$) in Estonia in 1998 to that in 2003?
Ensure brevity in your answer.  0.56. What is the ratio of the Value added (current US$) of Niger in 1998 to that in 2003?
Your response must be concise. 0.72. What is the ratio of the Value added (current US$) in South Africa in 1998 to that in 2003?
Provide a short and direct response. 0.76. What is the ratio of the Value added (current US$) in Chad in 1999 to that in 2000?
Offer a very short reply. 1.13. What is the ratio of the Value added (current US$) in Estonia in 1999 to that in 2000?
Give a very brief answer. 1.04. What is the ratio of the Value added (current US$) in Niger in 1999 to that in 2000?
Make the answer very short. 1.06. What is the ratio of the Value added (current US$) of South Africa in 1999 to that in 2000?
Offer a very short reply. 1.01. What is the ratio of the Value added (current US$) in Chad in 1999 to that in 2001?
Keep it short and to the point. 0.95. What is the ratio of the Value added (current US$) of Estonia in 1999 to that in 2001?
Your answer should be very brief. 0.95. What is the ratio of the Value added (current US$) in Niger in 1999 to that in 2001?
Provide a succinct answer. 1.02. What is the ratio of the Value added (current US$) in South Africa in 1999 to that in 2001?
Your answer should be very brief. 1.14. What is the ratio of the Value added (current US$) of Chad in 1999 to that in 2002?
Provide a succinct answer. 0.8. What is the ratio of the Value added (current US$) of Estonia in 1999 to that in 2002?
Ensure brevity in your answer.  0.81. What is the ratio of the Value added (current US$) of Niger in 1999 to that in 2002?
Give a very brief answer. 0.9. What is the ratio of the Value added (current US$) of South Africa in 1999 to that in 2002?
Ensure brevity in your answer.  1.2. What is the ratio of the Value added (current US$) of Chad in 1999 to that in 2003?
Ensure brevity in your answer.  0.63. What is the ratio of the Value added (current US$) in Estonia in 1999 to that in 2003?
Ensure brevity in your answer.  0.61. What is the ratio of the Value added (current US$) of Niger in 1999 to that in 2003?
Keep it short and to the point. 0.72. What is the ratio of the Value added (current US$) in South Africa in 1999 to that in 2003?
Your response must be concise. 0.77. What is the ratio of the Value added (current US$) of Chad in 2000 to that in 2001?
Ensure brevity in your answer.  0.84. What is the ratio of the Value added (current US$) in Estonia in 2000 to that in 2001?
Give a very brief answer. 0.92. What is the ratio of the Value added (current US$) of Niger in 2000 to that in 2001?
Your response must be concise. 0.95. What is the ratio of the Value added (current US$) of South Africa in 2000 to that in 2001?
Your response must be concise. 1.13. What is the ratio of the Value added (current US$) of Chad in 2000 to that in 2002?
Your answer should be very brief. 0.71. What is the ratio of the Value added (current US$) of Estonia in 2000 to that in 2002?
Your response must be concise. 0.78. What is the ratio of the Value added (current US$) of Niger in 2000 to that in 2002?
Your response must be concise. 0.85. What is the ratio of the Value added (current US$) in South Africa in 2000 to that in 2002?
Your answer should be very brief. 1.2. What is the ratio of the Value added (current US$) of Chad in 2000 to that in 2003?
Ensure brevity in your answer.  0.56. What is the ratio of the Value added (current US$) in Estonia in 2000 to that in 2003?
Offer a terse response. 0.58. What is the ratio of the Value added (current US$) in Niger in 2000 to that in 2003?
Offer a terse response. 0.68. What is the ratio of the Value added (current US$) of South Africa in 2000 to that in 2003?
Provide a succinct answer. 0.76. What is the ratio of the Value added (current US$) in Chad in 2001 to that in 2002?
Your answer should be very brief. 0.84. What is the ratio of the Value added (current US$) of Estonia in 2001 to that in 2002?
Ensure brevity in your answer.  0.85. What is the ratio of the Value added (current US$) in Niger in 2001 to that in 2002?
Provide a short and direct response. 0.89. What is the ratio of the Value added (current US$) in South Africa in 2001 to that in 2002?
Offer a terse response. 1.06. What is the ratio of the Value added (current US$) of Chad in 2001 to that in 2003?
Provide a succinct answer. 0.66. What is the ratio of the Value added (current US$) in Estonia in 2001 to that in 2003?
Provide a succinct answer. 0.64. What is the ratio of the Value added (current US$) of Niger in 2001 to that in 2003?
Your answer should be compact. 0.71. What is the ratio of the Value added (current US$) of South Africa in 2001 to that in 2003?
Give a very brief answer. 0.67. What is the ratio of the Value added (current US$) in Chad in 2002 to that in 2003?
Your answer should be very brief. 0.79. What is the ratio of the Value added (current US$) of Estonia in 2002 to that in 2003?
Make the answer very short. 0.75. What is the ratio of the Value added (current US$) in Niger in 2002 to that in 2003?
Keep it short and to the point. 0.8. What is the ratio of the Value added (current US$) in South Africa in 2002 to that in 2003?
Ensure brevity in your answer.  0.64. What is the difference between the highest and the second highest Value added (current US$) in Chad?
Provide a short and direct response. 2.32e+08. What is the difference between the highest and the second highest Value added (current US$) of Estonia?
Your response must be concise. 1.49e+09. What is the difference between the highest and the second highest Value added (current US$) of Niger?
Give a very brief answer. 2.38e+08. What is the difference between the highest and the second highest Value added (current US$) of South Africa?
Offer a terse response. 1.71e+1. What is the difference between the highest and the lowest Value added (current US$) in Chad?
Ensure brevity in your answer.  4.88e+08. What is the difference between the highest and the lowest Value added (current US$) in Estonia?
Your answer should be compact. 2.99e+09. What is the difference between the highest and the lowest Value added (current US$) of Niger?
Your answer should be very brief. 3.83e+08. What is the difference between the highest and the lowest Value added (current US$) of South Africa?
Make the answer very short. 3.80e+1. 